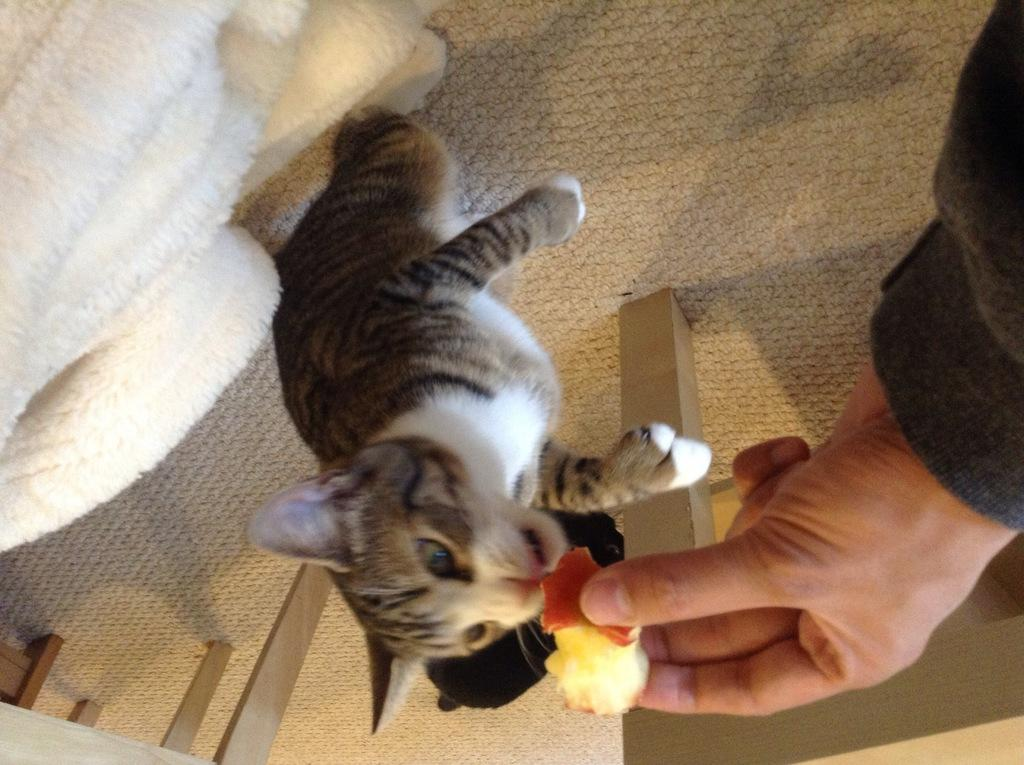What type of animal is in the image? There is a cat in the image. What is the person in the image doing with the cat? The person is hand-feeding the cat. Where is the cat sitting? The cat is sitting on a mat. What color is the cloth in the image? The cloth in the image is white. What type of birds can be seen flying in the image? There are no birds visible in the image; it features a cat being hand-fed by a person. 